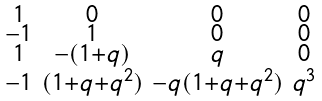Convert formula to latex. <formula><loc_0><loc_0><loc_500><loc_500>\begin{smallmatrix} 1 & 0 & 0 & 0 \\ - 1 & 1 & 0 & 0 \\ 1 & - ( 1 + q ) & q & 0 \\ - 1 & ( 1 + q + q ^ { 2 } ) & - q ( 1 + q + q ^ { 2 } ) & q ^ { 3 } \\ \end{smallmatrix}</formula> 